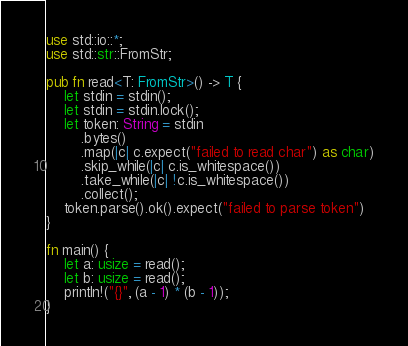<code> <loc_0><loc_0><loc_500><loc_500><_Rust_>use std::io::*;
use std::str::FromStr;

pub fn read<T: FromStr>() -> T {
    let stdin = stdin();
    let stdin = stdin.lock();
    let token: String = stdin
        .bytes()
        .map(|c| c.expect("failed to read char") as char)
        .skip_while(|c| c.is_whitespace())
        .take_while(|c| !c.is_whitespace())
        .collect();
    token.parse().ok().expect("failed to parse token")
}

fn main() {
    let a: usize = read();
    let b: usize = read();
    println!("{}", (a - 1) * (b - 1));
}
</code> 